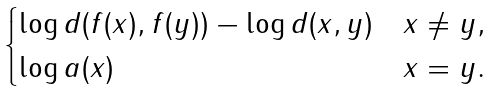<formula> <loc_0><loc_0><loc_500><loc_500>\begin{cases} \log d ( f ( x ) , f ( y ) ) - \log d ( x , y ) & x \neq y , \\ \log a ( x ) & x = y . \end{cases}</formula> 